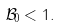Convert formula to latex. <formula><loc_0><loc_0><loc_500><loc_500>\mathcal { B } _ { 0 } < 1 .</formula> 